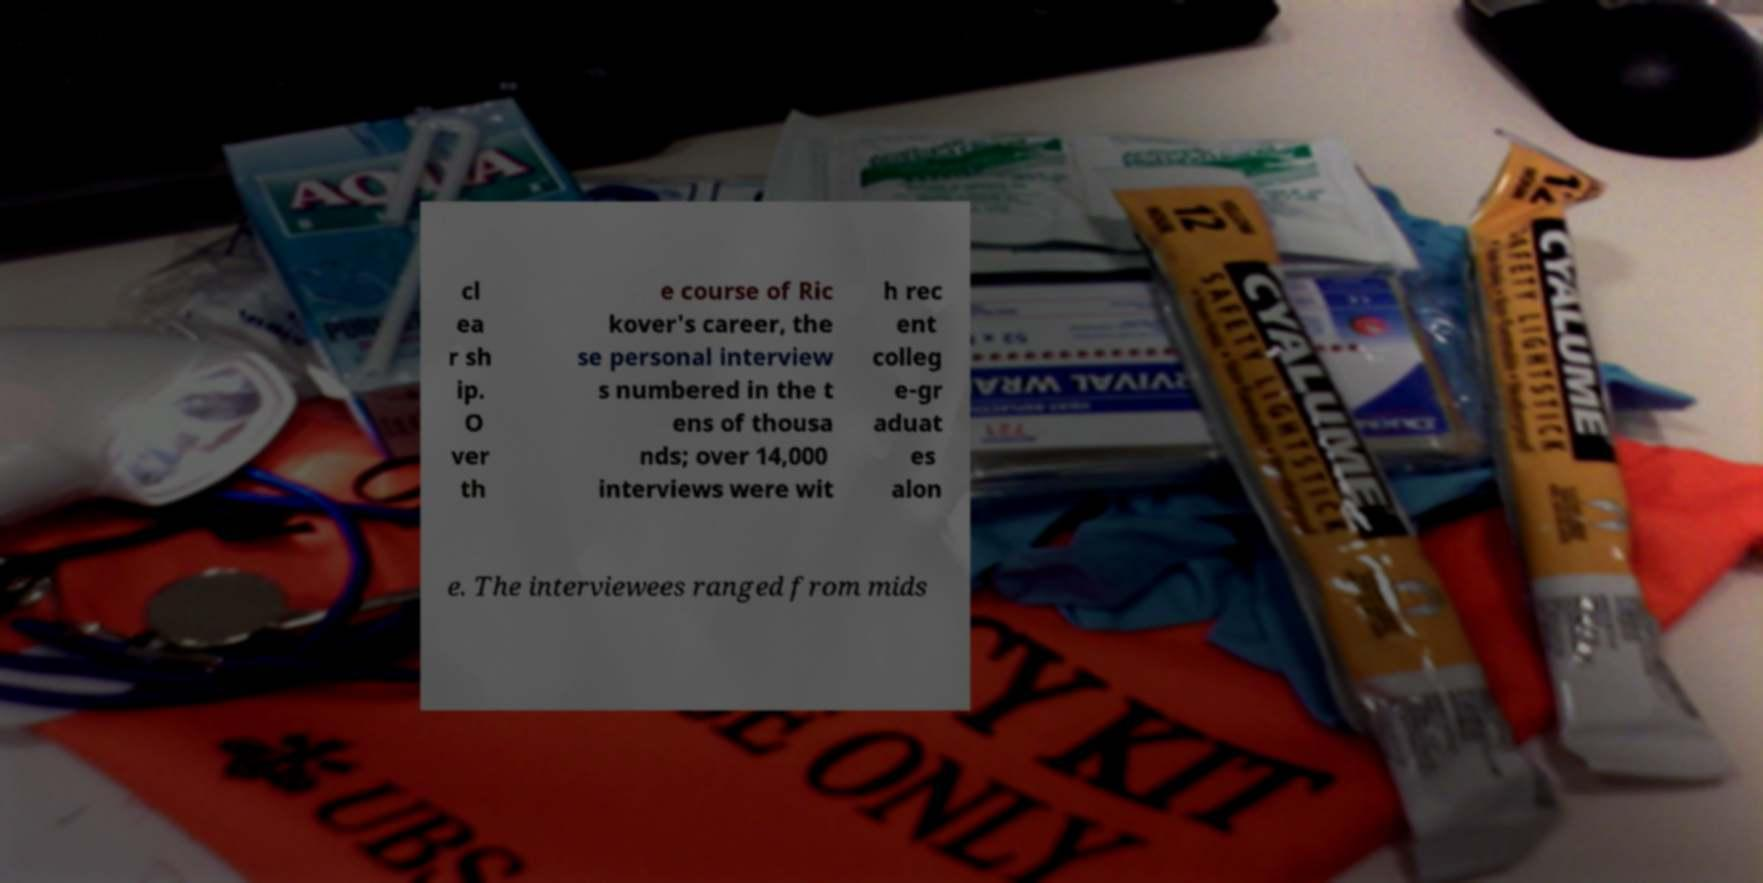Please identify and transcribe the text found in this image. cl ea r sh ip. O ver th e course of Ric kover's career, the se personal interview s numbered in the t ens of thousa nds; over 14,000 interviews were wit h rec ent colleg e-gr aduat es alon e. The interviewees ranged from mids 